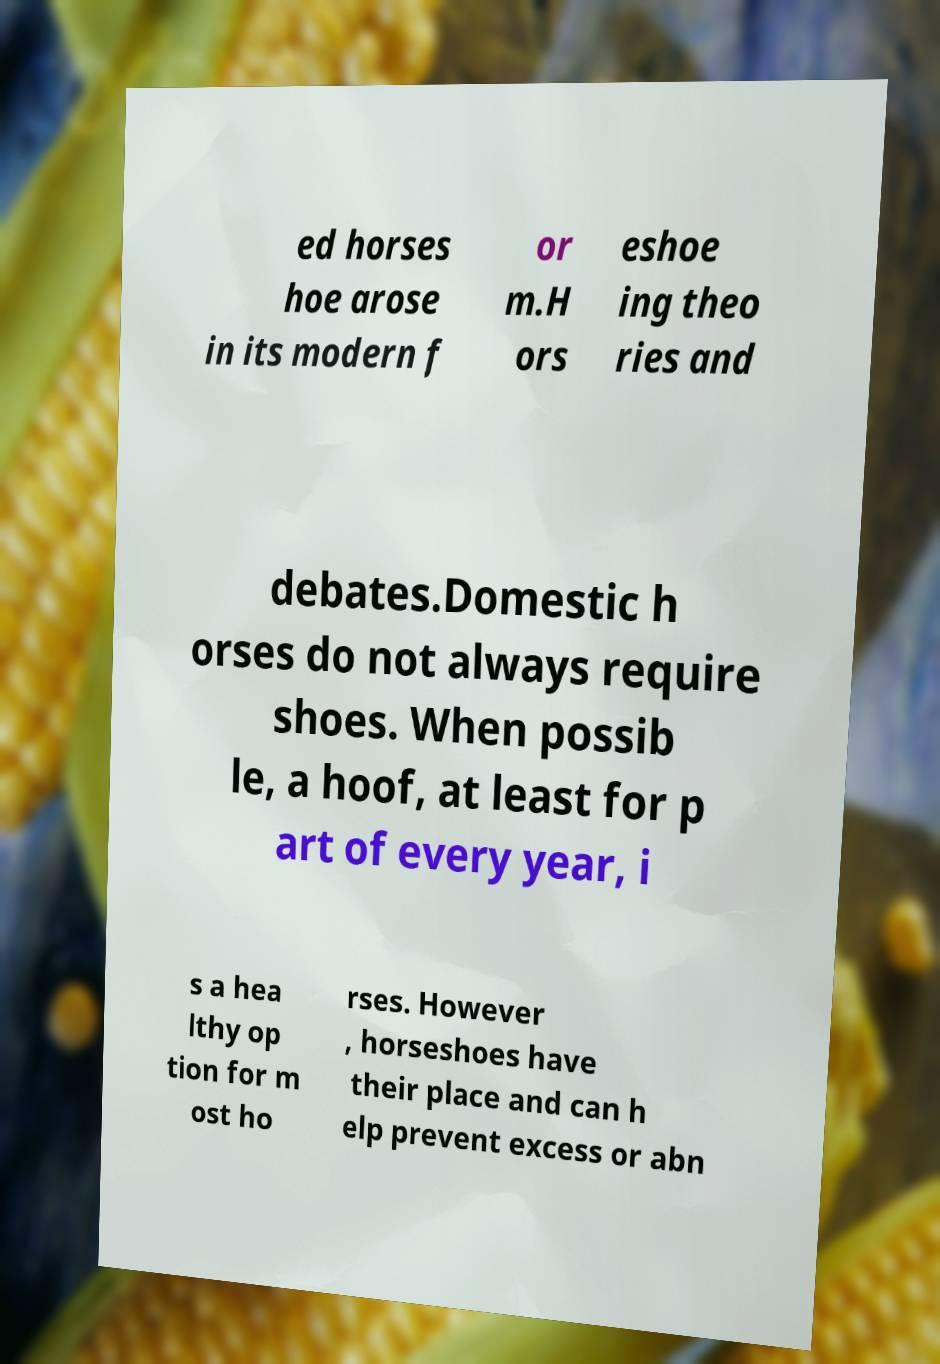Can you accurately transcribe the text from the provided image for me? ed horses hoe arose in its modern f or m.H ors eshoe ing theo ries and debates.Domestic h orses do not always require shoes. When possib le, a hoof, at least for p art of every year, i s a hea lthy op tion for m ost ho rses. However , horseshoes have their place and can h elp prevent excess or abn 